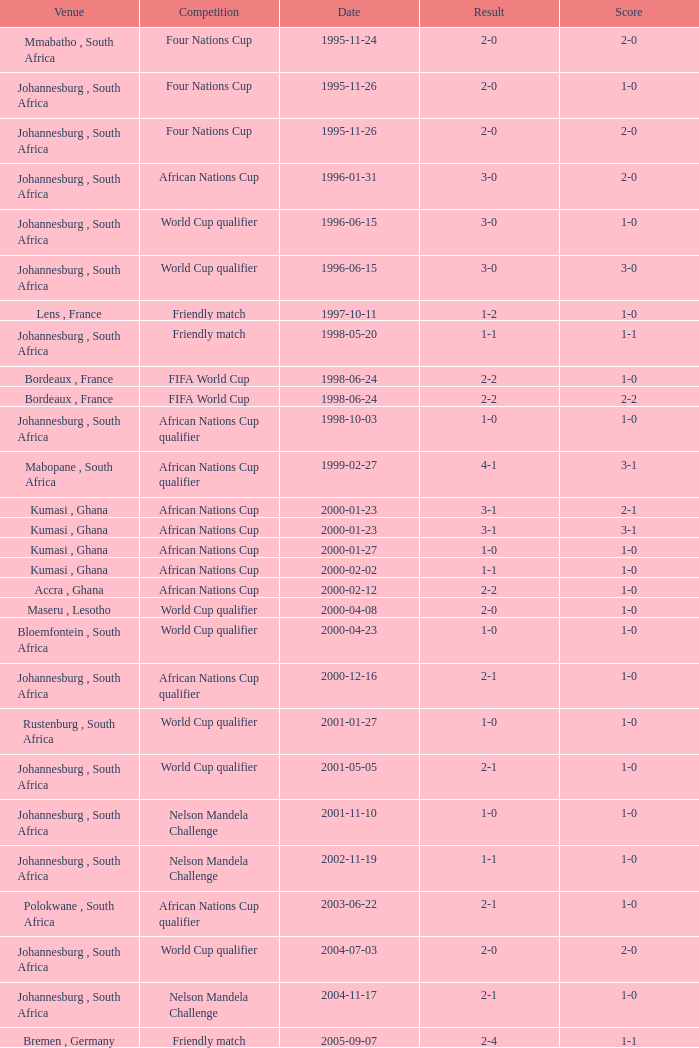What is the Date of the Fifa World Cup with a Score of 1-0? 1998-06-24. Give me the full table as a dictionary. {'header': ['Venue', 'Competition', 'Date', 'Result', 'Score'], 'rows': [['Mmabatho , South Africa', 'Four Nations Cup', '1995-11-24', '2-0', '2-0'], ['Johannesburg , South Africa', 'Four Nations Cup', '1995-11-26', '2-0', '1-0'], ['Johannesburg , South Africa', 'Four Nations Cup', '1995-11-26', '2-0', '2-0'], ['Johannesburg , South Africa', 'African Nations Cup', '1996-01-31', '3-0', '2-0'], ['Johannesburg , South Africa', 'World Cup qualifier', '1996-06-15', '3-0', '1-0'], ['Johannesburg , South Africa', 'World Cup qualifier', '1996-06-15', '3-0', '3-0'], ['Lens , France', 'Friendly match', '1997-10-11', '1-2', '1-0'], ['Johannesburg , South Africa', 'Friendly match', '1998-05-20', '1-1', '1-1'], ['Bordeaux , France', 'FIFA World Cup', '1998-06-24', '2-2', '1-0'], ['Bordeaux , France', 'FIFA World Cup', '1998-06-24', '2-2', '2-2'], ['Johannesburg , South Africa', 'African Nations Cup qualifier', '1998-10-03', '1-0', '1-0'], ['Mabopane , South Africa', 'African Nations Cup qualifier', '1999-02-27', '4-1', '3-1'], ['Kumasi , Ghana', 'African Nations Cup', '2000-01-23', '3-1', '2-1'], ['Kumasi , Ghana', 'African Nations Cup', '2000-01-23', '3-1', '3-1'], ['Kumasi , Ghana', 'African Nations Cup', '2000-01-27', '1-0', '1-0'], ['Kumasi , Ghana', 'African Nations Cup', '2000-02-02', '1-1', '1-0'], ['Accra , Ghana', 'African Nations Cup', '2000-02-12', '2-2', '1-0'], ['Maseru , Lesotho', 'World Cup qualifier', '2000-04-08', '2-0', '1-0'], ['Bloemfontein , South Africa', 'World Cup qualifier', '2000-04-23', '1-0', '1-0'], ['Johannesburg , South Africa', 'African Nations Cup qualifier', '2000-12-16', '2-1', '1-0'], ['Rustenburg , South Africa', 'World Cup qualifier', '2001-01-27', '1-0', '1-0'], ['Johannesburg , South Africa', 'World Cup qualifier', '2001-05-05', '2-1', '1-0'], ['Johannesburg , South Africa', 'Nelson Mandela Challenge', '2001-11-10', '1-0', '1-0'], ['Johannesburg , South Africa', 'Nelson Mandela Challenge', '2002-11-19', '1-1', '1-0'], ['Polokwane , South Africa', 'African Nations Cup qualifier', '2003-06-22', '2-1', '1-0'], ['Johannesburg , South Africa', 'World Cup qualifier', '2004-07-03', '2-0', '2-0'], ['Johannesburg , South Africa', 'Nelson Mandela Challenge', '2004-11-17', '2-1', '1-0'], ['Bremen , Germany', 'Friendly match', '2005-09-07', '2-4', '1-1']]} 